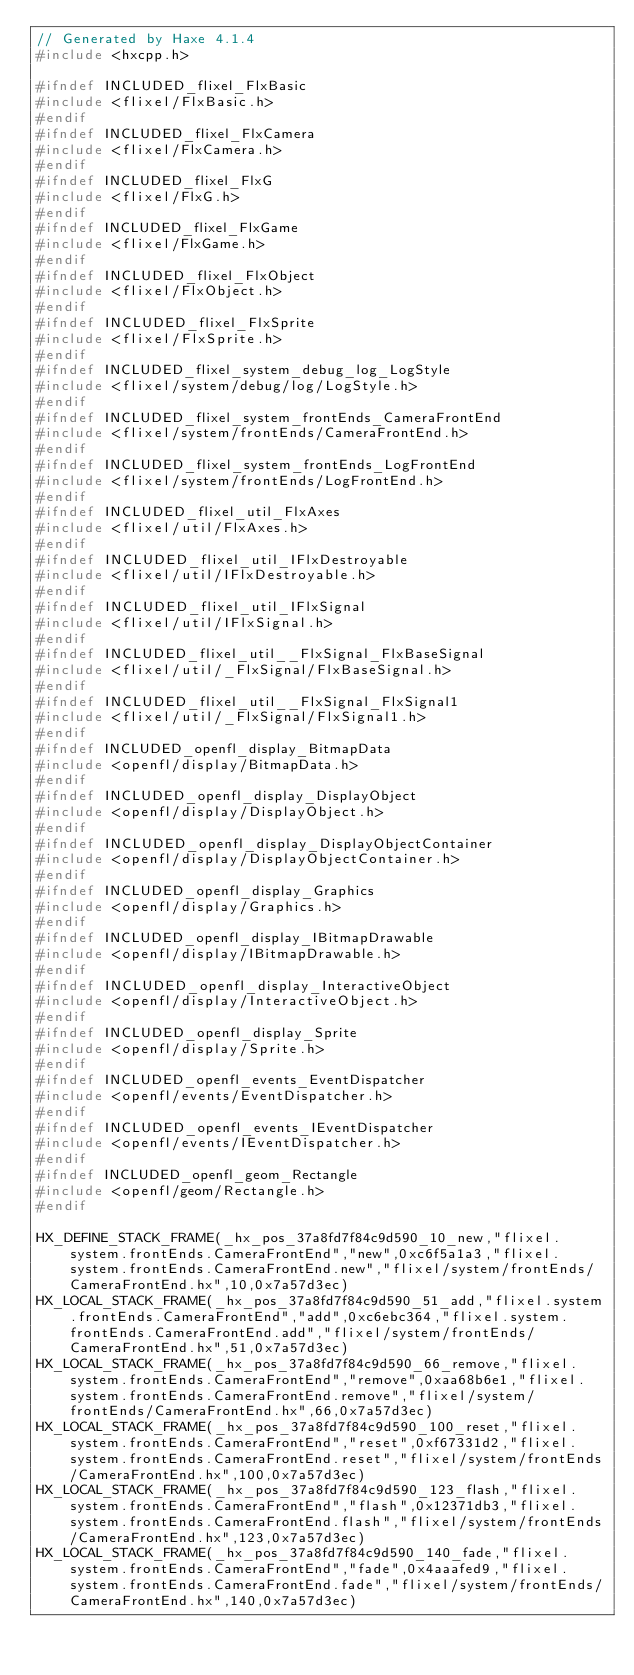Convert code to text. <code><loc_0><loc_0><loc_500><loc_500><_C++_>// Generated by Haxe 4.1.4
#include <hxcpp.h>

#ifndef INCLUDED_flixel_FlxBasic
#include <flixel/FlxBasic.h>
#endif
#ifndef INCLUDED_flixel_FlxCamera
#include <flixel/FlxCamera.h>
#endif
#ifndef INCLUDED_flixel_FlxG
#include <flixel/FlxG.h>
#endif
#ifndef INCLUDED_flixel_FlxGame
#include <flixel/FlxGame.h>
#endif
#ifndef INCLUDED_flixel_FlxObject
#include <flixel/FlxObject.h>
#endif
#ifndef INCLUDED_flixel_FlxSprite
#include <flixel/FlxSprite.h>
#endif
#ifndef INCLUDED_flixel_system_debug_log_LogStyle
#include <flixel/system/debug/log/LogStyle.h>
#endif
#ifndef INCLUDED_flixel_system_frontEnds_CameraFrontEnd
#include <flixel/system/frontEnds/CameraFrontEnd.h>
#endif
#ifndef INCLUDED_flixel_system_frontEnds_LogFrontEnd
#include <flixel/system/frontEnds/LogFrontEnd.h>
#endif
#ifndef INCLUDED_flixel_util_FlxAxes
#include <flixel/util/FlxAxes.h>
#endif
#ifndef INCLUDED_flixel_util_IFlxDestroyable
#include <flixel/util/IFlxDestroyable.h>
#endif
#ifndef INCLUDED_flixel_util_IFlxSignal
#include <flixel/util/IFlxSignal.h>
#endif
#ifndef INCLUDED_flixel_util__FlxSignal_FlxBaseSignal
#include <flixel/util/_FlxSignal/FlxBaseSignal.h>
#endif
#ifndef INCLUDED_flixel_util__FlxSignal_FlxSignal1
#include <flixel/util/_FlxSignal/FlxSignal1.h>
#endif
#ifndef INCLUDED_openfl_display_BitmapData
#include <openfl/display/BitmapData.h>
#endif
#ifndef INCLUDED_openfl_display_DisplayObject
#include <openfl/display/DisplayObject.h>
#endif
#ifndef INCLUDED_openfl_display_DisplayObjectContainer
#include <openfl/display/DisplayObjectContainer.h>
#endif
#ifndef INCLUDED_openfl_display_Graphics
#include <openfl/display/Graphics.h>
#endif
#ifndef INCLUDED_openfl_display_IBitmapDrawable
#include <openfl/display/IBitmapDrawable.h>
#endif
#ifndef INCLUDED_openfl_display_InteractiveObject
#include <openfl/display/InteractiveObject.h>
#endif
#ifndef INCLUDED_openfl_display_Sprite
#include <openfl/display/Sprite.h>
#endif
#ifndef INCLUDED_openfl_events_EventDispatcher
#include <openfl/events/EventDispatcher.h>
#endif
#ifndef INCLUDED_openfl_events_IEventDispatcher
#include <openfl/events/IEventDispatcher.h>
#endif
#ifndef INCLUDED_openfl_geom_Rectangle
#include <openfl/geom/Rectangle.h>
#endif

HX_DEFINE_STACK_FRAME(_hx_pos_37a8fd7f84c9d590_10_new,"flixel.system.frontEnds.CameraFrontEnd","new",0xc6f5a1a3,"flixel.system.frontEnds.CameraFrontEnd.new","flixel/system/frontEnds/CameraFrontEnd.hx",10,0x7a57d3ec)
HX_LOCAL_STACK_FRAME(_hx_pos_37a8fd7f84c9d590_51_add,"flixel.system.frontEnds.CameraFrontEnd","add",0xc6ebc364,"flixel.system.frontEnds.CameraFrontEnd.add","flixel/system/frontEnds/CameraFrontEnd.hx",51,0x7a57d3ec)
HX_LOCAL_STACK_FRAME(_hx_pos_37a8fd7f84c9d590_66_remove,"flixel.system.frontEnds.CameraFrontEnd","remove",0xaa68b6e1,"flixel.system.frontEnds.CameraFrontEnd.remove","flixel/system/frontEnds/CameraFrontEnd.hx",66,0x7a57d3ec)
HX_LOCAL_STACK_FRAME(_hx_pos_37a8fd7f84c9d590_100_reset,"flixel.system.frontEnds.CameraFrontEnd","reset",0xf67331d2,"flixel.system.frontEnds.CameraFrontEnd.reset","flixel/system/frontEnds/CameraFrontEnd.hx",100,0x7a57d3ec)
HX_LOCAL_STACK_FRAME(_hx_pos_37a8fd7f84c9d590_123_flash,"flixel.system.frontEnds.CameraFrontEnd","flash",0x12371db3,"flixel.system.frontEnds.CameraFrontEnd.flash","flixel/system/frontEnds/CameraFrontEnd.hx",123,0x7a57d3ec)
HX_LOCAL_STACK_FRAME(_hx_pos_37a8fd7f84c9d590_140_fade,"flixel.system.frontEnds.CameraFrontEnd","fade",0x4aaafed9,"flixel.system.frontEnds.CameraFrontEnd.fade","flixel/system/frontEnds/CameraFrontEnd.hx",140,0x7a57d3ec)</code> 